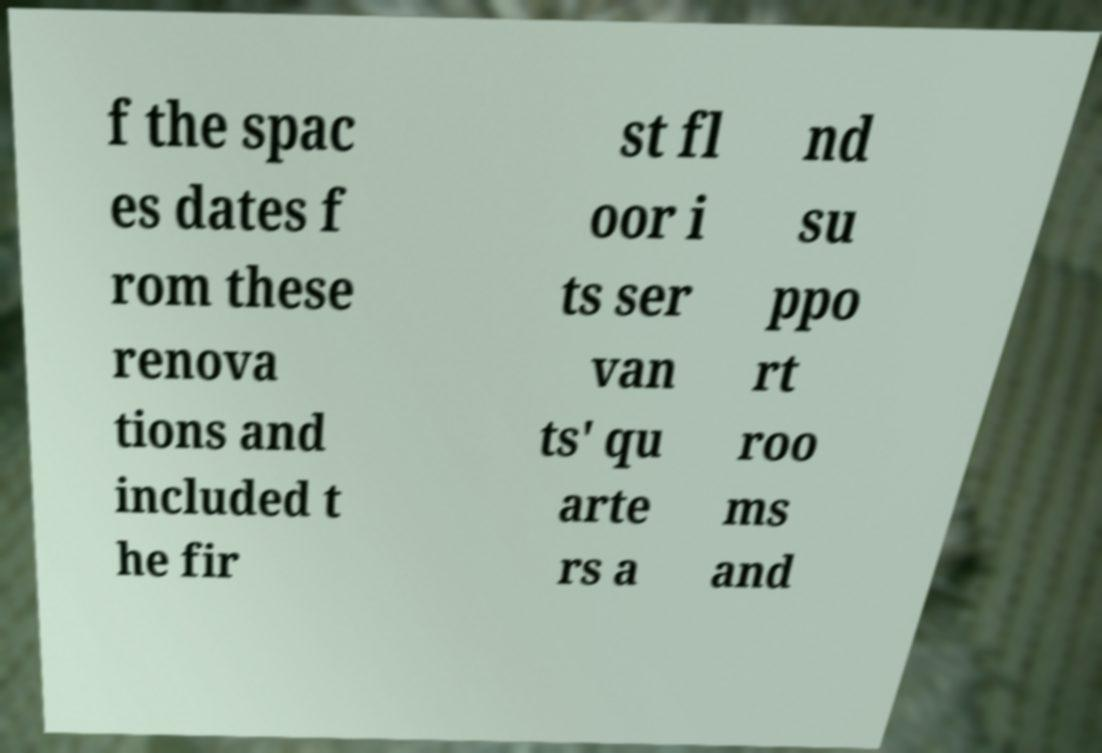Could you extract and type out the text from this image? f the spac es dates f rom these renova tions and included t he fir st fl oor i ts ser van ts' qu arte rs a nd su ppo rt roo ms and 